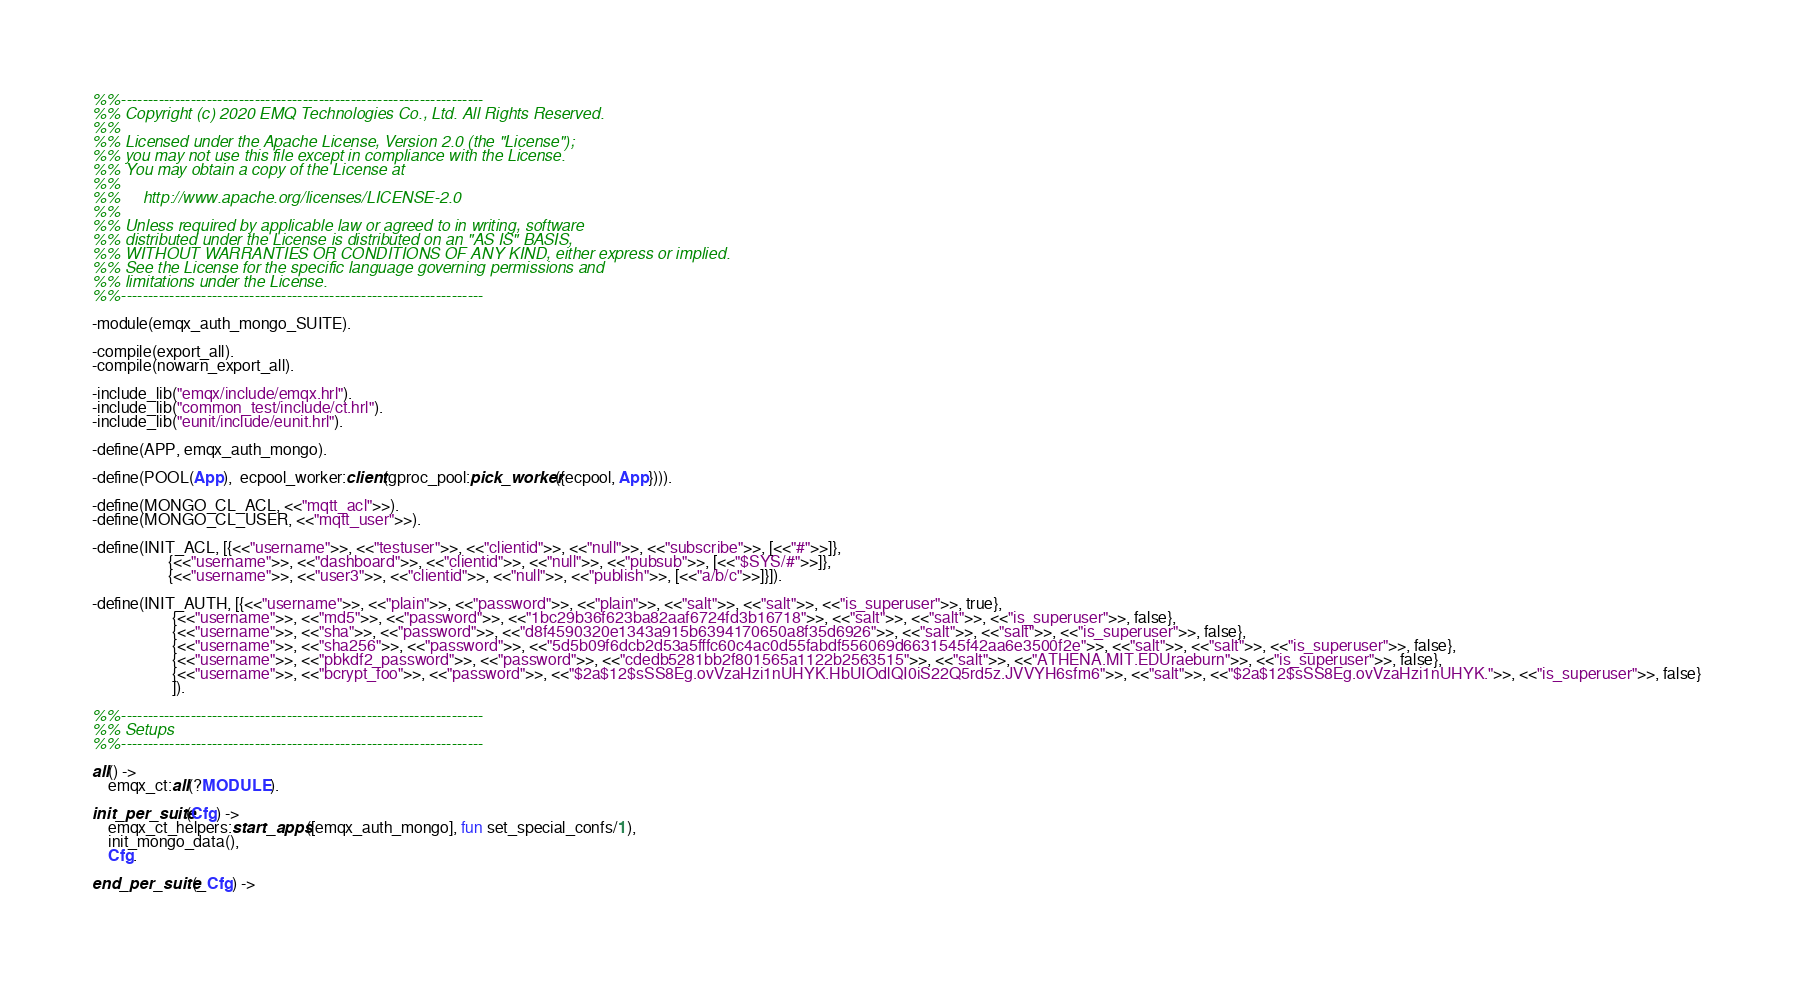<code> <loc_0><loc_0><loc_500><loc_500><_Erlang_>%%--------------------------------------------------------------------
%% Copyright (c) 2020 EMQ Technologies Co., Ltd. All Rights Reserved.
%%
%% Licensed under the Apache License, Version 2.0 (the "License");
%% you may not use this file except in compliance with the License.
%% You may obtain a copy of the License at
%%
%%     http://www.apache.org/licenses/LICENSE-2.0
%%
%% Unless required by applicable law or agreed to in writing, software
%% distributed under the License is distributed on an "AS IS" BASIS,
%% WITHOUT WARRANTIES OR CONDITIONS OF ANY KIND, either express or implied.
%% See the License for the specific language governing permissions and
%% limitations under the License.
%%--------------------------------------------------------------------

-module(emqx_auth_mongo_SUITE).

-compile(export_all).
-compile(nowarn_export_all).

-include_lib("emqx/include/emqx.hrl").
-include_lib("common_test/include/ct.hrl").
-include_lib("eunit/include/eunit.hrl").

-define(APP, emqx_auth_mongo).

-define(POOL(App),  ecpool_worker:client(gproc_pool:pick_worker({ecpool, App}))).

-define(MONGO_CL_ACL, <<"mqtt_acl">>).
-define(MONGO_CL_USER, <<"mqtt_user">>).

-define(INIT_ACL, [{<<"username">>, <<"testuser">>, <<"clientid">>, <<"null">>, <<"subscribe">>, [<<"#">>]},
                   {<<"username">>, <<"dashboard">>, <<"clientid">>, <<"null">>, <<"pubsub">>, [<<"$SYS/#">>]},
                   {<<"username">>, <<"user3">>, <<"clientid">>, <<"null">>, <<"publish">>, [<<"a/b/c">>]}]).

-define(INIT_AUTH, [{<<"username">>, <<"plain">>, <<"password">>, <<"plain">>, <<"salt">>, <<"salt">>, <<"is_superuser">>, true},
                    {<<"username">>, <<"md5">>, <<"password">>, <<"1bc29b36f623ba82aaf6724fd3b16718">>, <<"salt">>, <<"salt">>, <<"is_superuser">>, false},
                    {<<"username">>, <<"sha">>, <<"password">>, <<"d8f4590320e1343a915b6394170650a8f35d6926">>, <<"salt">>, <<"salt">>, <<"is_superuser">>, false},
                    {<<"username">>, <<"sha256">>, <<"password">>, <<"5d5b09f6dcb2d53a5fffc60c4ac0d55fabdf556069d6631545f42aa6e3500f2e">>, <<"salt">>, <<"salt">>, <<"is_superuser">>, false},
                    {<<"username">>, <<"pbkdf2_password">>, <<"password">>, <<"cdedb5281bb2f801565a1122b2563515">>, <<"salt">>, <<"ATHENA.MIT.EDUraeburn">>, <<"is_superuser">>, false},
                    {<<"username">>, <<"bcrypt_foo">>, <<"password">>, <<"$2a$12$sSS8Eg.ovVzaHzi1nUHYK.HbUIOdlQI0iS22Q5rd5z.JVVYH6sfm6">>, <<"salt">>, <<"$2a$12$sSS8Eg.ovVzaHzi1nUHYK.">>, <<"is_superuser">>, false}
                    ]).

%%--------------------------------------------------------------------
%% Setups
%%--------------------------------------------------------------------

all() ->
    emqx_ct:all(?MODULE).

init_per_suite(Cfg) ->
    emqx_ct_helpers:start_apps([emqx_auth_mongo], fun set_special_confs/1),
    init_mongo_data(),
    Cfg.

end_per_suite(_Cfg) -></code> 